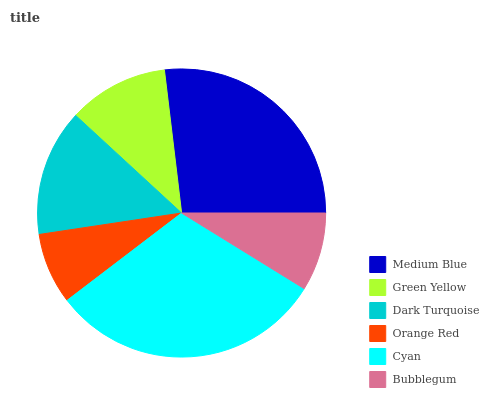Is Orange Red the minimum?
Answer yes or no. Yes. Is Cyan the maximum?
Answer yes or no. Yes. Is Green Yellow the minimum?
Answer yes or no. No. Is Green Yellow the maximum?
Answer yes or no. No. Is Medium Blue greater than Green Yellow?
Answer yes or no. Yes. Is Green Yellow less than Medium Blue?
Answer yes or no. Yes. Is Green Yellow greater than Medium Blue?
Answer yes or no. No. Is Medium Blue less than Green Yellow?
Answer yes or no. No. Is Dark Turquoise the high median?
Answer yes or no. Yes. Is Green Yellow the low median?
Answer yes or no. Yes. Is Green Yellow the high median?
Answer yes or no. No. Is Orange Red the low median?
Answer yes or no. No. 